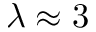Convert formula to latex. <formula><loc_0><loc_0><loc_500><loc_500>\lambda \approx 3</formula> 